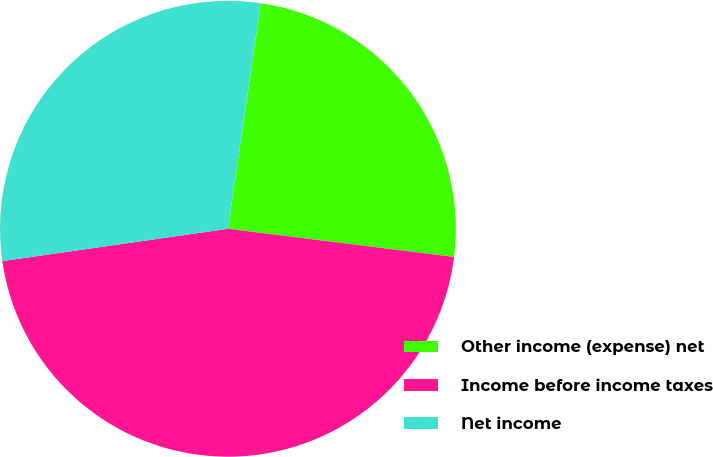<chart> <loc_0><loc_0><loc_500><loc_500><pie_chart><fcel>Other income (expense) net<fcel>Income before income taxes<fcel>Net income<nl><fcel>24.67%<fcel>45.76%<fcel>29.57%<nl></chart> 